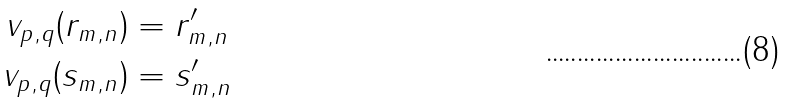Convert formula to latex. <formula><loc_0><loc_0><loc_500><loc_500>v _ { p , q } ( r _ { m , n } ) & = r ^ { \prime } _ { m , n } \\ v _ { p , q } ( s _ { m , n } ) & = s ^ { \prime } _ { m , n }</formula> 